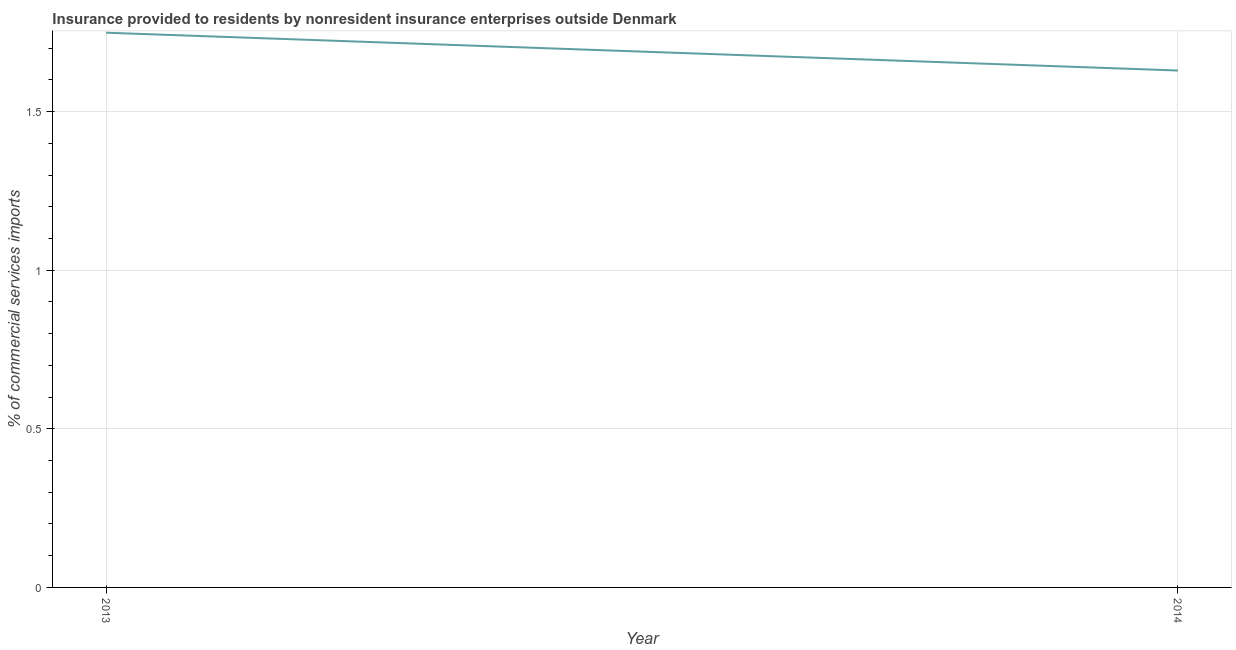What is the insurance provided by non-residents in 2013?
Provide a short and direct response. 1.75. Across all years, what is the maximum insurance provided by non-residents?
Your response must be concise. 1.75. Across all years, what is the minimum insurance provided by non-residents?
Provide a succinct answer. 1.63. In which year was the insurance provided by non-residents maximum?
Provide a short and direct response. 2013. In which year was the insurance provided by non-residents minimum?
Your answer should be compact. 2014. What is the sum of the insurance provided by non-residents?
Provide a succinct answer. 3.38. What is the difference between the insurance provided by non-residents in 2013 and 2014?
Ensure brevity in your answer.  0.12. What is the average insurance provided by non-residents per year?
Your answer should be very brief. 1.69. What is the median insurance provided by non-residents?
Give a very brief answer. 1.69. In how many years, is the insurance provided by non-residents greater than 0.8 %?
Offer a very short reply. 2. What is the ratio of the insurance provided by non-residents in 2013 to that in 2014?
Your answer should be compact. 1.07. Is the insurance provided by non-residents in 2013 less than that in 2014?
Provide a succinct answer. No. In how many years, is the insurance provided by non-residents greater than the average insurance provided by non-residents taken over all years?
Offer a terse response. 1. Does the insurance provided by non-residents monotonically increase over the years?
Your answer should be compact. No. What is the difference between two consecutive major ticks on the Y-axis?
Provide a succinct answer. 0.5. What is the title of the graph?
Your answer should be very brief. Insurance provided to residents by nonresident insurance enterprises outside Denmark. What is the label or title of the Y-axis?
Give a very brief answer. % of commercial services imports. What is the % of commercial services imports of 2013?
Keep it short and to the point. 1.75. What is the % of commercial services imports of 2014?
Give a very brief answer. 1.63. What is the difference between the % of commercial services imports in 2013 and 2014?
Your response must be concise. 0.12. What is the ratio of the % of commercial services imports in 2013 to that in 2014?
Ensure brevity in your answer.  1.07. 